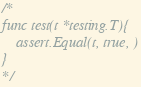Convert code to text. <code><loc_0><loc_0><loc_500><loc_500><_Go_>
/*
func test(t *testing.T){
	assert.Equal(t, true, )
}
*/
</code> 